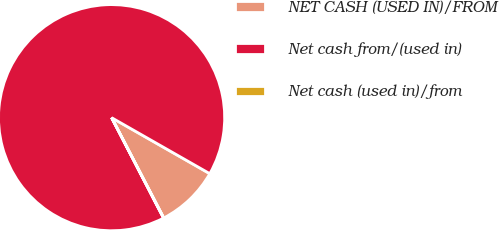Convert chart. <chart><loc_0><loc_0><loc_500><loc_500><pie_chart><fcel>NET CASH (USED IN)/FROM<fcel>Net cash from/(used in)<fcel>Net cash (used in)/from<nl><fcel>9.12%<fcel>90.85%<fcel>0.04%<nl></chart> 